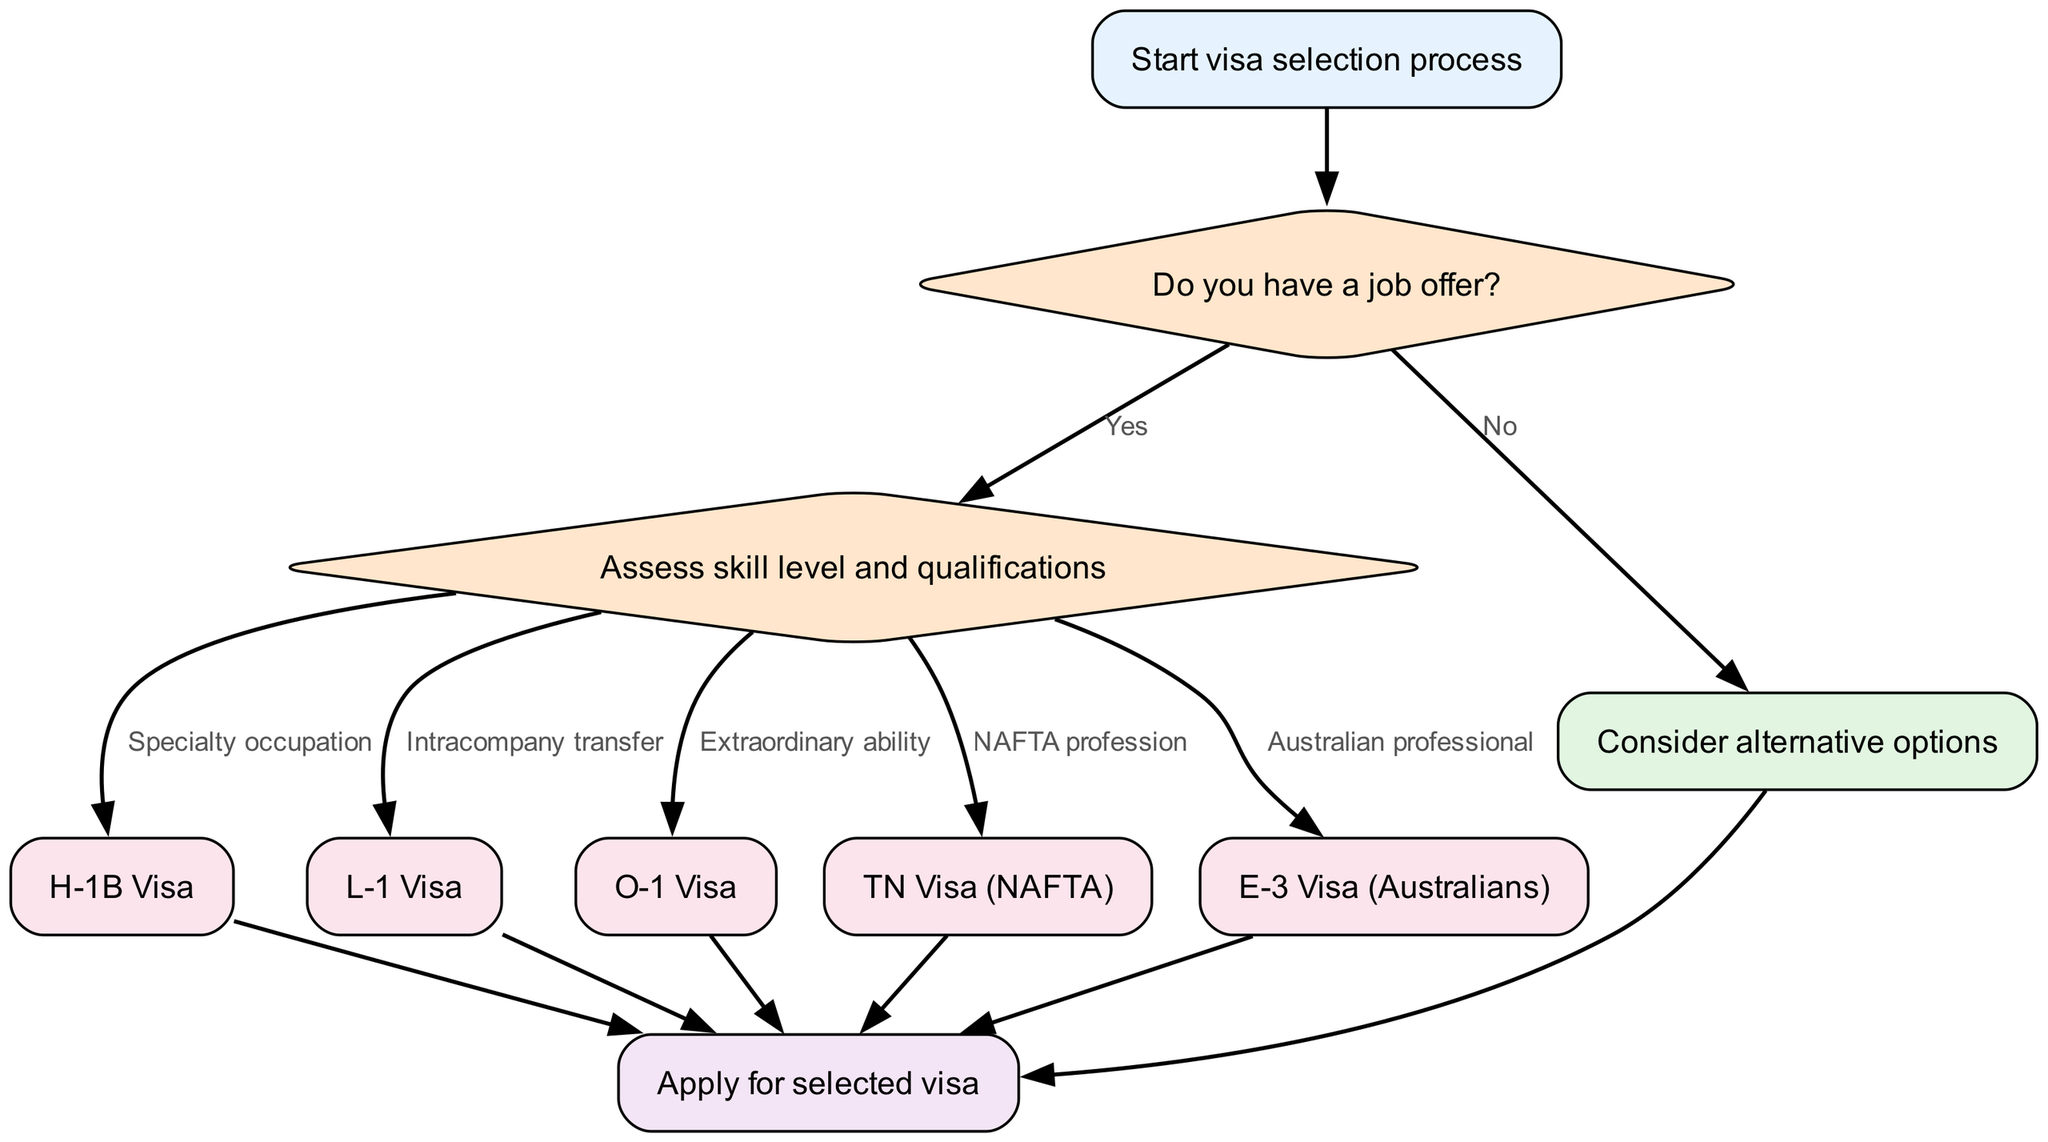What's the starting point of the diagram? The starting point is indicated as "Start visa selection process," which is the first node in the diagram and initiates the flow of the decision-making process.
Answer: Start visa selection process How many visa types are listed in the diagram? The diagram lists five distinct visa types: H-1B Visa, L-1 Visa, O-1 Visa, TN Visa (NAFTA), and E-3 Visa (Australians). Therefore, the total count of visa types is five.
Answer: Five What follows after assessing skill level and qualifications? After assessing skill level and qualifications, one of several visa options will be chosen depending on the specific qualification category, leading to either an H-1B, L-1, O-1, TN, or E-3 Visa.
Answer: H-1B Visa, L-1 Visa, O-1 Visa, TN Visa, E-3 Visa What happens if there is no job offer? If there is no job offer, the decision-making process leads to considering alternative options instead of moving forward to assessing qualifications.
Answer: Consider alternative options If someone qualifies for an extraordinary ability visa, what is the next step? If someone qualifies for an extraordinary ability visa (O-1), they proceed directly to the application stage upon selecting this visa type.
Answer: Apply for selected visa How does one reach the end of the diagram? The end of the diagram is reached from any of the visa types or from the alternative options node, all of which lead to the final step of applying for the selected visa.
Answer: Apply for selected visa What is the decision point in the flowchart? The decision points in the flowchart are represented by two diamond-shaped nodes: “Do you have a job offer?” and “Assess skill level and qualifications.”
Answer: Do you have a job offer? and Assess skill level and qualifications Which visa is associated with NAFTA professions? The visa associated with NAFTA professions, as per the diagram, is the TN Visa.
Answer: TN Visa (NAFTA) What is the first decision node in the flowchart? The first decision node in the flowchart is "Do you have a job offer?" which determines the subsequent steps in the process.
Answer: Do you have a job offer? 